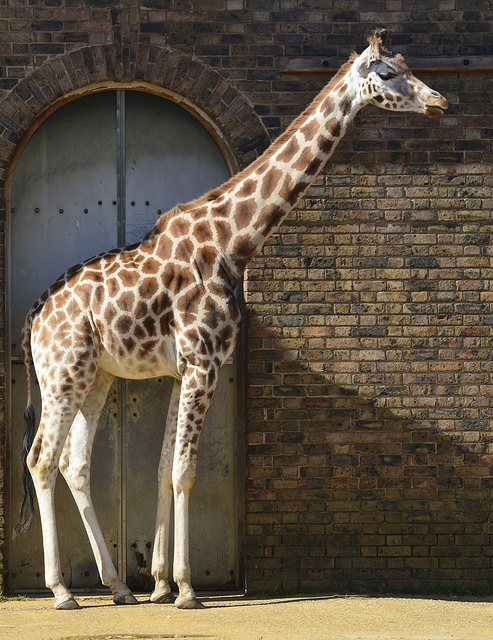Describe the objects in this image and their specific colors. I can see a giraffe in black, ivory, gray, and tan tones in this image. 